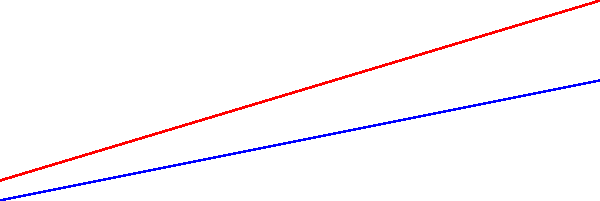As a budget-conscious event planner, you're organizing a party and need to determine the optimal amount of food and drink. The graph shows the relationship between guest count and the required amounts of food (in kg) and drink (in L). If you're expecting 175 guests, how much money will you save by purchasing the exact amount needed instead of rounding up to the next plotted point?

Assume:
- Food costs $5 per kg
- Drink costs $2 per L
- You would round up to 200 guests if not calculating exactly Let's approach this step-by-step:

1. For 175 guests, we need to interpolate between 150 and 200 guests:

   For food: 
   $$(175 - 150) / (200 - 150) = 0.5$$
   $$45 + (60 - 45) * 0.5 = 52.5 \text{ kg}$$

   For drink:
   $$(175 - 150) / (200 - 150) = 0.5$$
   $$30 + (40 - 30) * 0.5 = 35 \text{ L}$$

2. Exact amount cost:
   $$52.5 \text{ kg} * $5/\text{kg} + 35 \text{ L} * $2/\text{L} = $262.50 + $70 = $332.50$$

3. Rounded up amount (200 guests):
   $$60 \text{ kg} * $5/\text{kg} + 40 \text{ L} * $2/\text{L} = $300 + $80 = $380$$

4. Savings:
   $$380 - $332.50 = $47.50$$
Answer: $47.50 